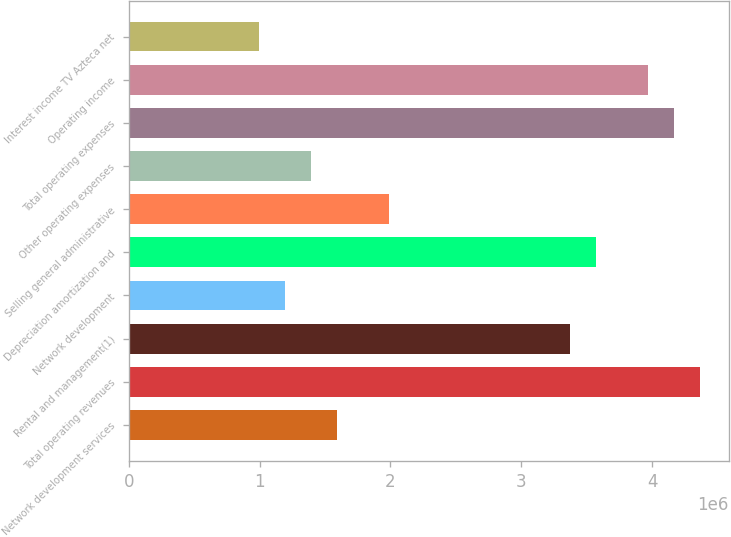Convert chart. <chart><loc_0><loc_0><loc_500><loc_500><bar_chart><fcel>Network development services<fcel>Total operating revenues<fcel>Rental and management(1)<fcel>Network development<fcel>Depreciation amortization and<fcel>Selling general administrative<fcel>Other operating expenses<fcel>Total operating expenses<fcel>Operating income<fcel>Interest income TV Azteca net<nl><fcel>1.58827e+06<fcel>4.36774e+06<fcel>3.37507e+06<fcel>1.1912e+06<fcel>3.5736e+06<fcel>1.98534e+06<fcel>1.38973e+06<fcel>4.1692e+06<fcel>3.97067e+06<fcel>992668<nl></chart> 